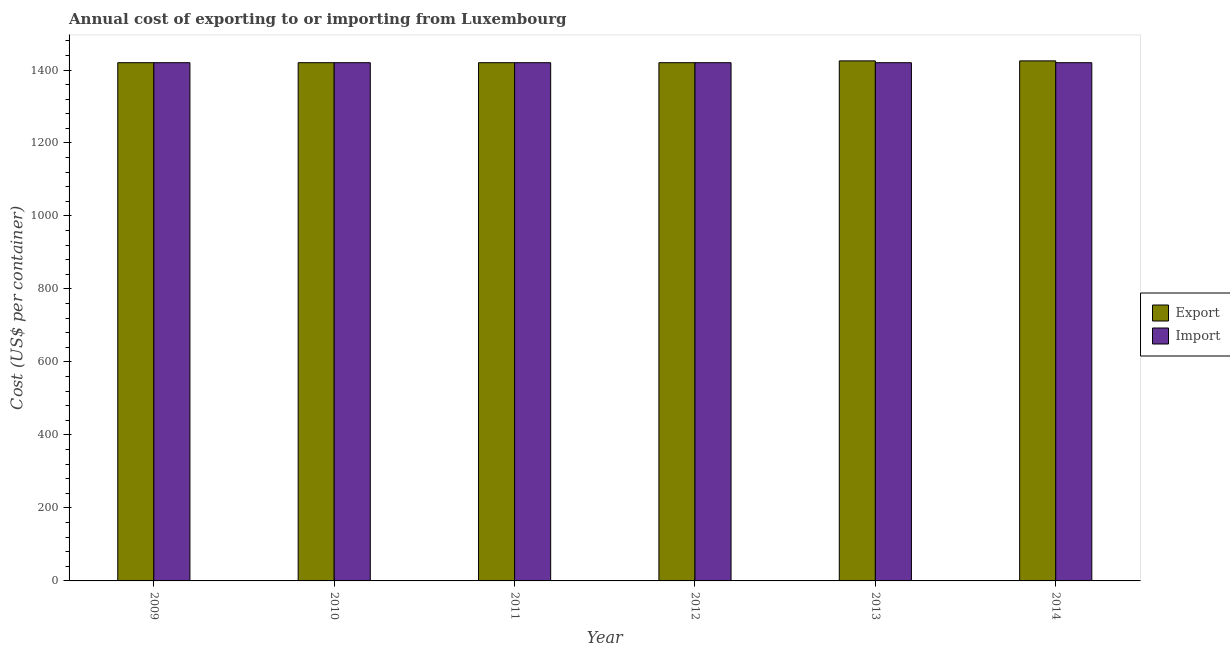How many different coloured bars are there?
Make the answer very short. 2. How many groups of bars are there?
Make the answer very short. 6. Are the number of bars per tick equal to the number of legend labels?
Provide a short and direct response. Yes. Are the number of bars on each tick of the X-axis equal?
Provide a short and direct response. Yes. What is the label of the 3rd group of bars from the left?
Ensure brevity in your answer.  2011. In how many cases, is the number of bars for a given year not equal to the number of legend labels?
Provide a short and direct response. 0. What is the export cost in 2014?
Your answer should be compact. 1425. Across all years, what is the maximum import cost?
Ensure brevity in your answer.  1420. Across all years, what is the minimum import cost?
Ensure brevity in your answer.  1420. What is the total export cost in the graph?
Make the answer very short. 8530. What is the difference between the export cost in 2013 and the import cost in 2009?
Offer a very short reply. 5. What is the average import cost per year?
Your response must be concise. 1420. In the year 2014, what is the difference between the export cost and import cost?
Give a very brief answer. 0. In how many years, is the import cost greater than 1280 US$?
Provide a succinct answer. 6. What is the ratio of the import cost in 2011 to that in 2013?
Provide a short and direct response. 1. Is the export cost in 2010 less than that in 2014?
Ensure brevity in your answer.  Yes. What is the difference between the highest and the second highest import cost?
Give a very brief answer. 0. What is the difference between the highest and the lowest export cost?
Provide a short and direct response. 5. Is the sum of the export cost in 2011 and 2014 greater than the maximum import cost across all years?
Offer a very short reply. Yes. What does the 2nd bar from the left in 2012 represents?
Keep it short and to the point. Import. What does the 2nd bar from the right in 2009 represents?
Give a very brief answer. Export. How many bars are there?
Keep it short and to the point. 12. Are all the bars in the graph horizontal?
Offer a terse response. No. What is the difference between two consecutive major ticks on the Y-axis?
Your answer should be very brief. 200. How many legend labels are there?
Ensure brevity in your answer.  2. What is the title of the graph?
Your answer should be very brief. Annual cost of exporting to or importing from Luxembourg. Does "Official aid received" appear as one of the legend labels in the graph?
Give a very brief answer. No. What is the label or title of the X-axis?
Make the answer very short. Year. What is the label or title of the Y-axis?
Your response must be concise. Cost (US$ per container). What is the Cost (US$ per container) in Export in 2009?
Your answer should be compact. 1420. What is the Cost (US$ per container) of Import in 2009?
Your answer should be very brief. 1420. What is the Cost (US$ per container) in Export in 2010?
Offer a very short reply. 1420. What is the Cost (US$ per container) of Import in 2010?
Give a very brief answer. 1420. What is the Cost (US$ per container) in Export in 2011?
Your answer should be compact. 1420. What is the Cost (US$ per container) in Import in 2011?
Provide a short and direct response. 1420. What is the Cost (US$ per container) in Export in 2012?
Your answer should be compact. 1420. What is the Cost (US$ per container) in Import in 2012?
Your answer should be very brief. 1420. What is the Cost (US$ per container) of Export in 2013?
Your response must be concise. 1425. What is the Cost (US$ per container) of Import in 2013?
Provide a succinct answer. 1420. What is the Cost (US$ per container) of Export in 2014?
Your answer should be compact. 1425. What is the Cost (US$ per container) in Import in 2014?
Offer a terse response. 1420. Across all years, what is the maximum Cost (US$ per container) of Export?
Offer a terse response. 1425. Across all years, what is the maximum Cost (US$ per container) of Import?
Provide a succinct answer. 1420. Across all years, what is the minimum Cost (US$ per container) in Export?
Give a very brief answer. 1420. Across all years, what is the minimum Cost (US$ per container) in Import?
Your answer should be compact. 1420. What is the total Cost (US$ per container) of Export in the graph?
Your response must be concise. 8530. What is the total Cost (US$ per container) of Import in the graph?
Offer a very short reply. 8520. What is the difference between the Cost (US$ per container) of Import in 2009 and that in 2010?
Your answer should be compact. 0. What is the difference between the Cost (US$ per container) in Import in 2009 and that in 2011?
Your answer should be very brief. 0. What is the difference between the Cost (US$ per container) of Export in 2009 and that in 2012?
Offer a very short reply. 0. What is the difference between the Cost (US$ per container) of Import in 2009 and that in 2012?
Your answer should be very brief. 0. What is the difference between the Cost (US$ per container) of Export in 2009 and that in 2013?
Provide a short and direct response. -5. What is the difference between the Cost (US$ per container) in Import in 2009 and that in 2013?
Offer a very short reply. 0. What is the difference between the Cost (US$ per container) of Export in 2009 and that in 2014?
Give a very brief answer. -5. What is the difference between the Cost (US$ per container) in Import in 2010 and that in 2011?
Your response must be concise. 0. What is the difference between the Cost (US$ per container) of Import in 2010 and that in 2012?
Give a very brief answer. 0. What is the difference between the Cost (US$ per container) in Export in 2010 and that in 2014?
Provide a succinct answer. -5. What is the difference between the Cost (US$ per container) in Import in 2011 and that in 2012?
Offer a very short reply. 0. What is the difference between the Cost (US$ per container) in Export in 2011 and that in 2013?
Give a very brief answer. -5. What is the difference between the Cost (US$ per container) in Export in 2011 and that in 2014?
Give a very brief answer. -5. What is the difference between the Cost (US$ per container) of Import in 2012 and that in 2014?
Provide a succinct answer. 0. What is the difference between the Cost (US$ per container) in Import in 2013 and that in 2014?
Your answer should be compact. 0. What is the difference between the Cost (US$ per container) of Export in 2009 and the Cost (US$ per container) of Import in 2012?
Your answer should be compact. 0. What is the difference between the Cost (US$ per container) in Export in 2009 and the Cost (US$ per container) in Import in 2013?
Provide a short and direct response. 0. What is the difference between the Cost (US$ per container) of Export in 2009 and the Cost (US$ per container) of Import in 2014?
Ensure brevity in your answer.  0. What is the difference between the Cost (US$ per container) of Export in 2010 and the Cost (US$ per container) of Import in 2012?
Your answer should be compact. 0. What is the difference between the Cost (US$ per container) of Export in 2011 and the Cost (US$ per container) of Import in 2013?
Provide a short and direct response. 0. What is the difference between the Cost (US$ per container) of Export in 2011 and the Cost (US$ per container) of Import in 2014?
Provide a short and direct response. 0. What is the average Cost (US$ per container) in Export per year?
Your answer should be very brief. 1421.67. What is the average Cost (US$ per container) in Import per year?
Provide a short and direct response. 1420. In the year 2009, what is the difference between the Cost (US$ per container) of Export and Cost (US$ per container) of Import?
Your answer should be compact. 0. In the year 2010, what is the difference between the Cost (US$ per container) of Export and Cost (US$ per container) of Import?
Keep it short and to the point. 0. In the year 2011, what is the difference between the Cost (US$ per container) in Export and Cost (US$ per container) in Import?
Ensure brevity in your answer.  0. In the year 2013, what is the difference between the Cost (US$ per container) of Export and Cost (US$ per container) of Import?
Ensure brevity in your answer.  5. What is the ratio of the Cost (US$ per container) of Export in 2009 to that in 2010?
Offer a terse response. 1. What is the ratio of the Cost (US$ per container) in Export in 2009 to that in 2011?
Offer a terse response. 1. What is the ratio of the Cost (US$ per container) in Import in 2009 to that in 2012?
Ensure brevity in your answer.  1. What is the ratio of the Cost (US$ per container) of Export in 2009 to that in 2013?
Your response must be concise. 1. What is the ratio of the Cost (US$ per container) in Import in 2009 to that in 2013?
Keep it short and to the point. 1. What is the ratio of the Cost (US$ per container) of Import in 2010 to that in 2011?
Your answer should be very brief. 1. What is the ratio of the Cost (US$ per container) in Export in 2010 to that in 2012?
Your answer should be compact. 1. What is the ratio of the Cost (US$ per container) of Import in 2010 to that in 2012?
Your answer should be very brief. 1. What is the ratio of the Cost (US$ per container) in Export in 2010 to that in 2013?
Offer a terse response. 1. What is the ratio of the Cost (US$ per container) of Export in 2010 to that in 2014?
Ensure brevity in your answer.  1. What is the ratio of the Cost (US$ per container) in Export in 2011 to that in 2012?
Your answer should be compact. 1. What is the ratio of the Cost (US$ per container) in Export in 2011 to that in 2013?
Provide a succinct answer. 1. What is the ratio of the Cost (US$ per container) of Export in 2011 to that in 2014?
Give a very brief answer. 1. What is the ratio of the Cost (US$ per container) of Export in 2012 to that in 2013?
Your answer should be compact. 1. What is the ratio of the Cost (US$ per container) in Import in 2012 to that in 2013?
Provide a succinct answer. 1. What is the ratio of the Cost (US$ per container) in Export in 2013 to that in 2014?
Keep it short and to the point. 1. What is the ratio of the Cost (US$ per container) in Import in 2013 to that in 2014?
Make the answer very short. 1. 